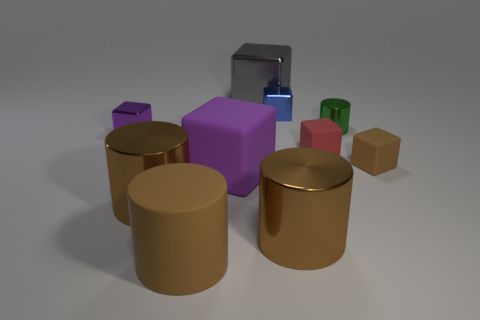Subtract all red spheres. How many brown cylinders are left? 3 Subtract all blue blocks. How many blocks are left? 5 Subtract all tiny brown cubes. How many cubes are left? 5 Subtract all red blocks. Subtract all purple cylinders. How many blocks are left? 5 Subtract all cylinders. How many objects are left? 6 Subtract all gray metallic cubes. Subtract all gray objects. How many objects are left? 8 Add 1 gray metallic things. How many gray metallic things are left? 2 Add 9 tiny green cylinders. How many tiny green cylinders exist? 10 Subtract 1 gray cubes. How many objects are left? 9 